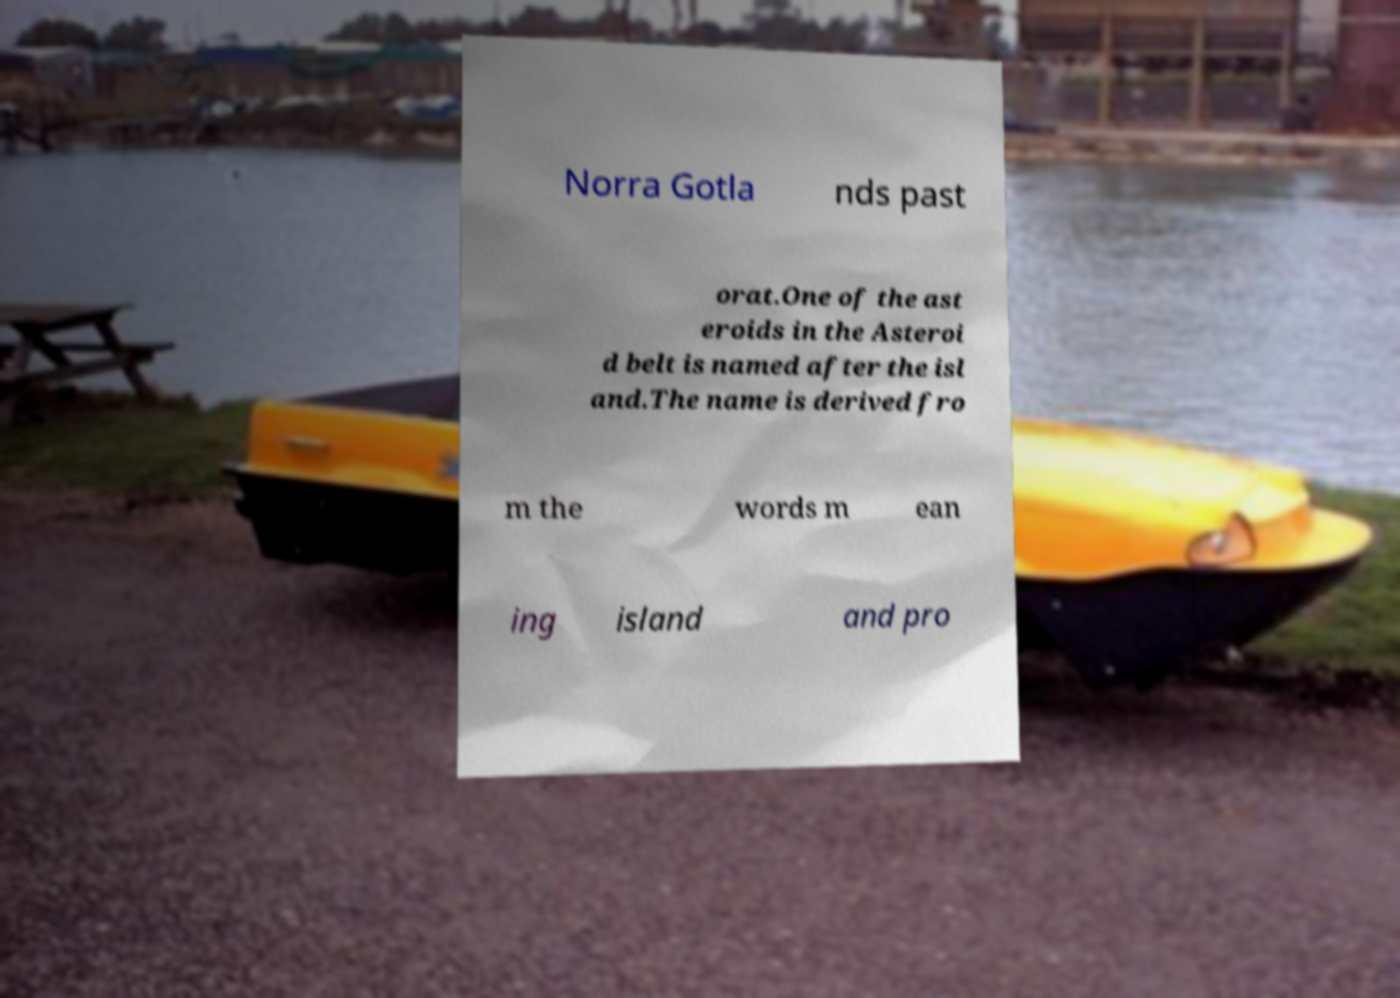Could you assist in decoding the text presented in this image and type it out clearly? Norra Gotla nds past orat.One of the ast eroids in the Asteroi d belt is named after the isl and.The name is derived fro m the words m ean ing island and pro 